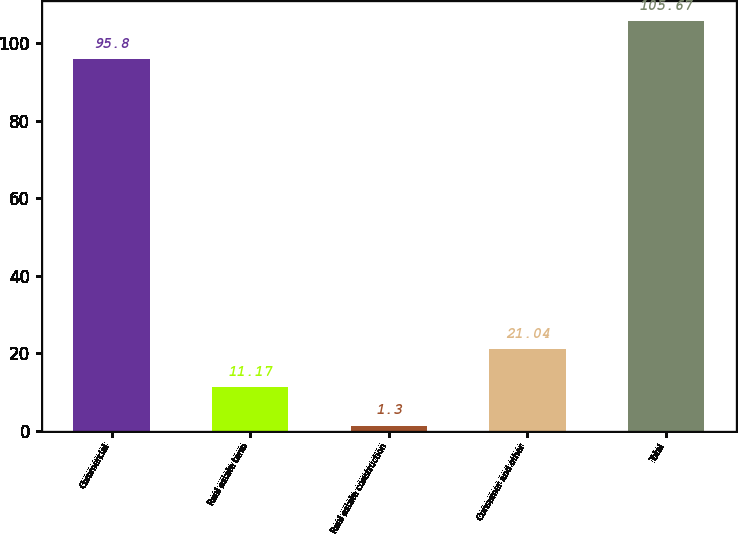Convert chart. <chart><loc_0><loc_0><loc_500><loc_500><bar_chart><fcel>Commercial<fcel>Real estate term<fcel>Real estate construction<fcel>Consumer and other<fcel>Total<nl><fcel>95.8<fcel>11.17<fcel>1.3<fcel>21.04<fcel>105.67<nl></chart> 